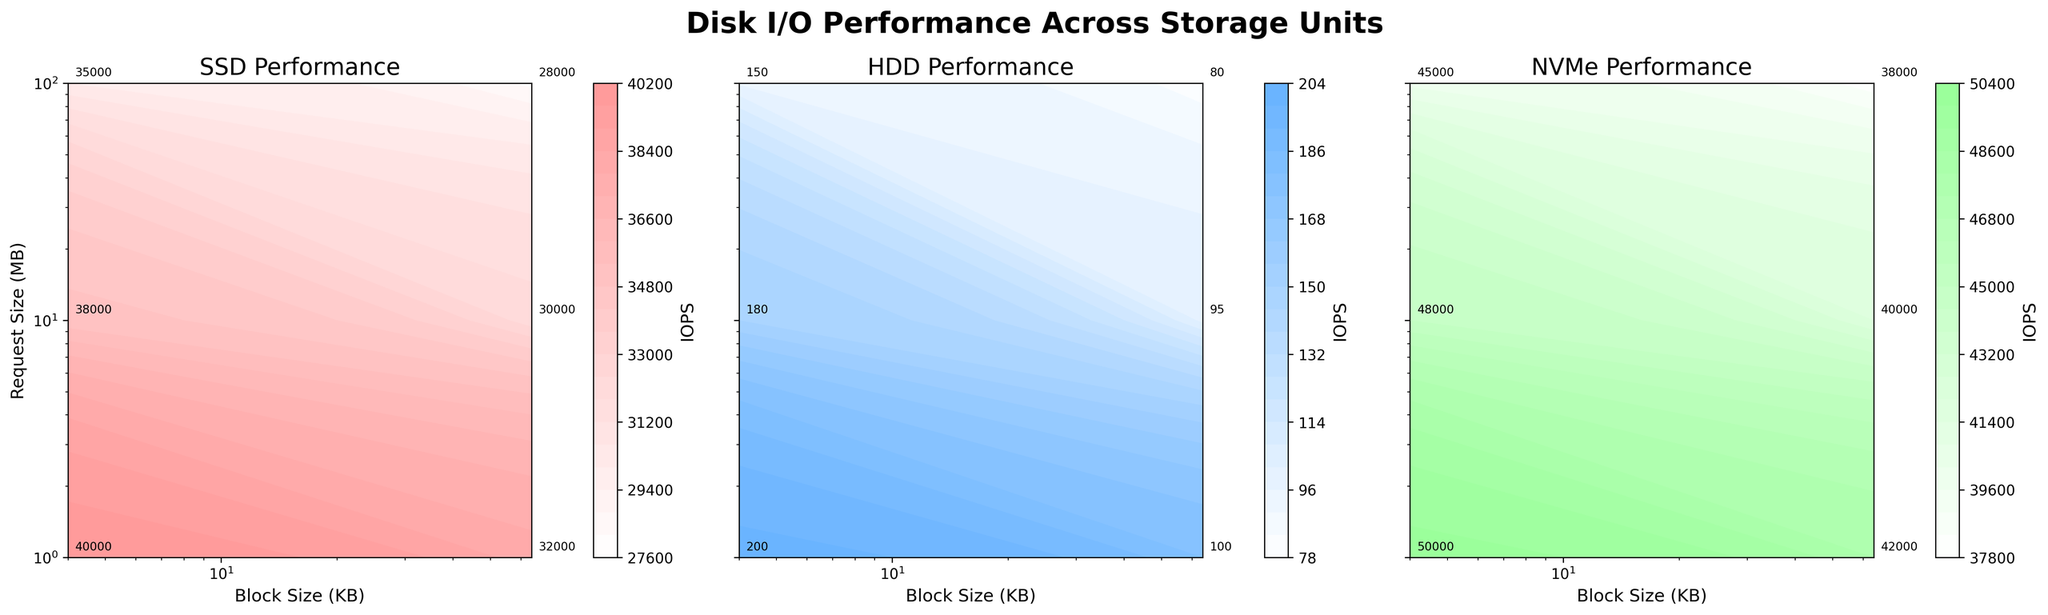How many unique storage types are presented in the figure? The figure has three subplots, each titled with a different storage type.
Answer: 3 What is the title of the figure? The title is shown at the top of the figure as a large, bold text.
Answer: Disk I/O Performance Across Storage Units Which storage type shows the highest IOPS value? By comparing the highest labeled values in all three subplots, NVMe shows an IOPS value of 50000.
Answer: NVMe What are the block sizes used in the SSD performance plot? The X-axis of the SSD subplot shows block sizes, which range across a few specific values.
Answer: 4 KB and 64 KB Compare IOPS for SSD and HDD when the Block Size is 4 KB and Request Size is 1 MB. Checking the contour plots for SSD and HDD at Block Size 4 KB and Request Size 1 MB, the SSD IOPS is 40000 and HDD IOPS is 200.
Answer: SSD: 40000, HDD: 200 How does the IOPS change with Request Size for NVMe when Block Size is constant at 64 KB? By looking at the NVMe subplot, and analyzing the contour labels at Block Size 64 KB, the IOPS decreases as Request Size increases from 1 MB to 100 MB (42000 -> 40000 -> 38000).
Answer: Decreases What is the Request Size range used in the plots? The Y-axis across all subplots shows the range of Request Size values.
Answer: 1 MB to 100 MB Does HDD performance vary more with Block Size or Request Size? Observing the contour lines in the HDD subplot, the IOPS changes significantly more when varying Block Size from 4 KB to 64 KB compared to Request Size changes.
Answer: Block Size Which subplot uses a blue color scheme? By checking the color shading in the subplots, HDD is represented with a blue color.
Answer: HDD Given a Request Size of 10 MB and Block Size of 64 KB, which storage type provides the highest IOPS? Examining the labels in each subplot under these conditions, NVMe has the highest IOPS of 40000.
Answer: NVMe 